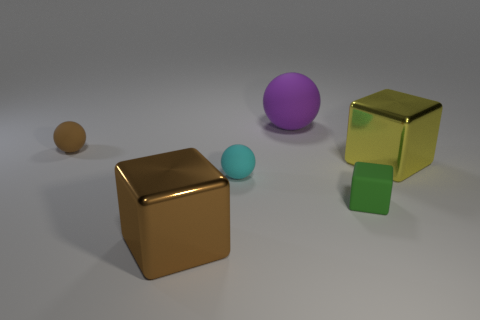Are there an equal number of large yellow objects to the left of the brown block and large brown things that are to the right of the tiny brown matte ball?
Your answer should be compact. No. The big thing behind the small brown object is what color?
Provide a short and direct response. Purple. Is the number of yellow objects less than the number of big purple metal cylinders?
Keep it short and to the point. No. How many purple matte objects are the same size as the brown matte object?
Your answer should be compact. 0. Are the small brown object and the tiny cyan ball made of the same material?
Offer a very short reply. Yes. What number of purple things are the same shape as the cyan thing?
Your answer should be very brief. 1. What shape is the large thing that is made of the same material as the tiny cyan object?
Provide a succinct answer. Sphere. There is a matte sphere in front of the big cube to the right of the big rubber sphere; what is its color?
Provide a short and direct response. Cyan. What is the material of the large block on the right side of the large object that is to the left of the big ball?
Ensure brevity in your answer.  Metal. There is a large brown object that is the same shape as the green rubber object; what is its material?
Provide a short and direct response. Metal. 